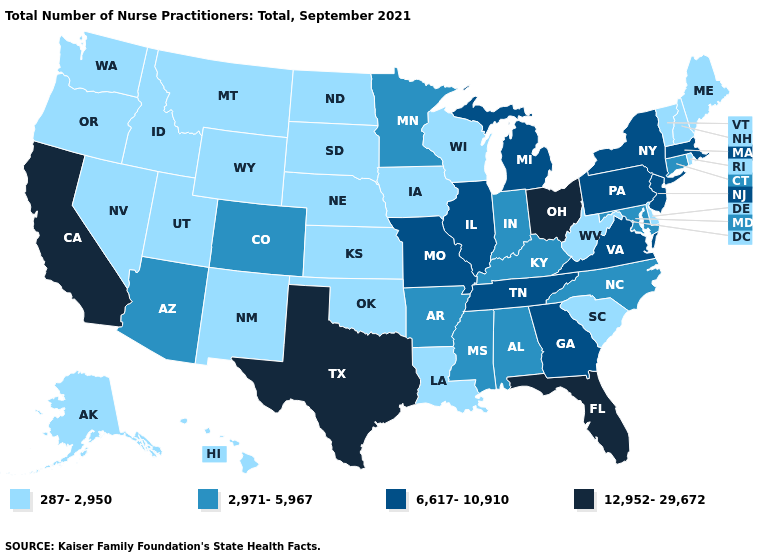What is the value of Indiana?
Give a very brief answer. 2,971-5,967. Name the states that have a value in the range 12,952-29,672?
Be succinct. California, Florida, Ohio, Texas. What is the value of West Virginia?
Concise answer only. 287-2,950. What is the value of Idaho?
Quick response, please. 287-2,950. Does Florida have the highest value in the USA?
Concise answer only. Yes. Is the legend a continuous bar?
Keep it brief. No. Does the first symbol in the legend represent the smallest category?
Quick response, please. Yes. Name the states that have a value in the range 287-2,950?
Give a very brief answer. Alaska, Delaware, Hawaii, Idaho, Iowa, Kansas, Louisiana, Maine, Montana, Nebraska, Nevada, New Hampshire, New Mexico, North Dakota, Oklahoma, Oregon, Rhode Island, South Carolina, South Dakota, Utah, Vermont, Washington, West Virginia, Wisconsin, Wyoming. What is the value of Texas?
Quick response, please. 12,952-29,672. Does the map have missing data?
Write a very short answer. No. What is the value of Nebraska?
Answer briefly. 287-2,950. What is the value of Maine?
Answer briefly. 287-2,950. What is the value of Oregon?
Write a very short answer. 287-2,950. Is the legend a continuous bar?
Short answer required. No. Which states have the highest value in the USA?
Answer briefly. California, Florida, Ohio, Texas. 